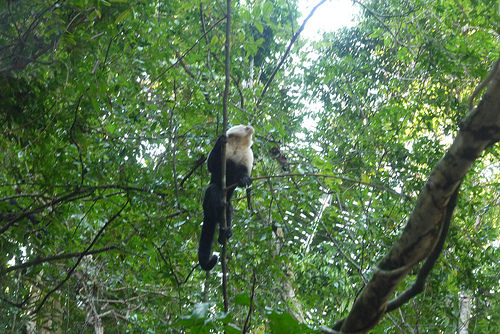<image>
Can you confirm if the monkey is on the tree? Yes. Looking at the image, I can see the monkey is positioned on top of the tree, with the tree providing support. Where is the animal in relation to the tree? Is it on the tree? No. The animal is not positioned on the tree. They may be near each other, but the animal is not supported by or resting on top of the tree. 